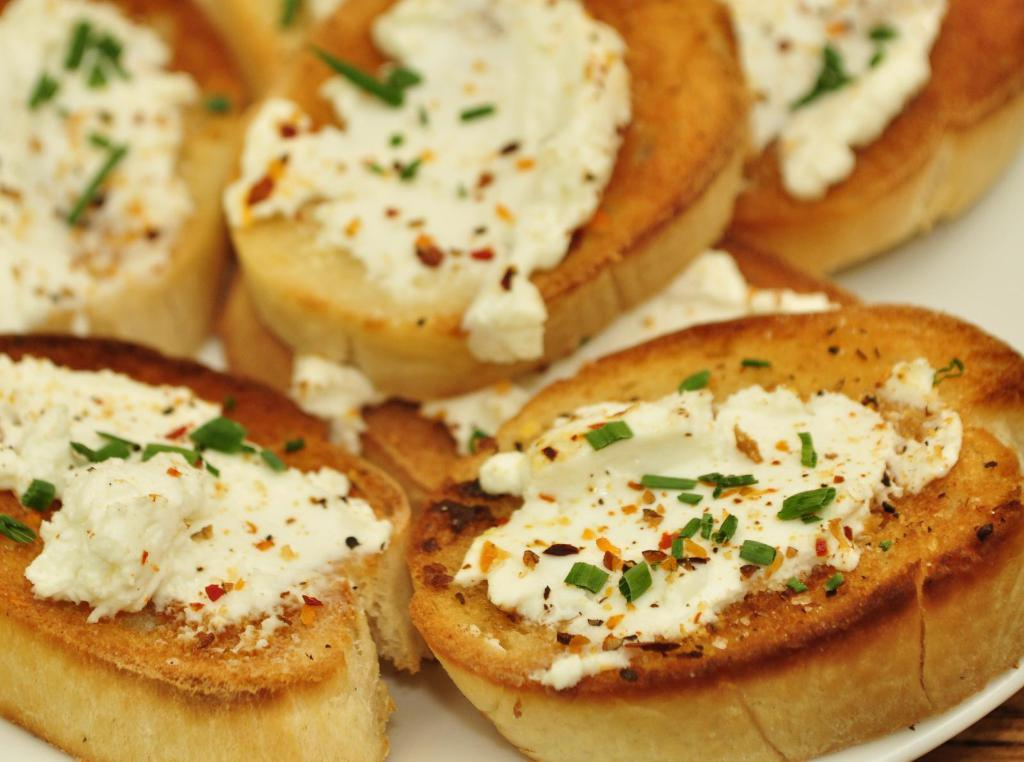What is visible on the breadcrumbs in the image? Cheese is present on the breadcrumbs in the image. Are there any other ingredients on the breadcrumbs? Yes, there are other ingredients on the breadcrumbs. What type of rhythm can be heard coming from the shirt in the image? There is no shirt present in the image, and therefore no rhythm can be heard. 